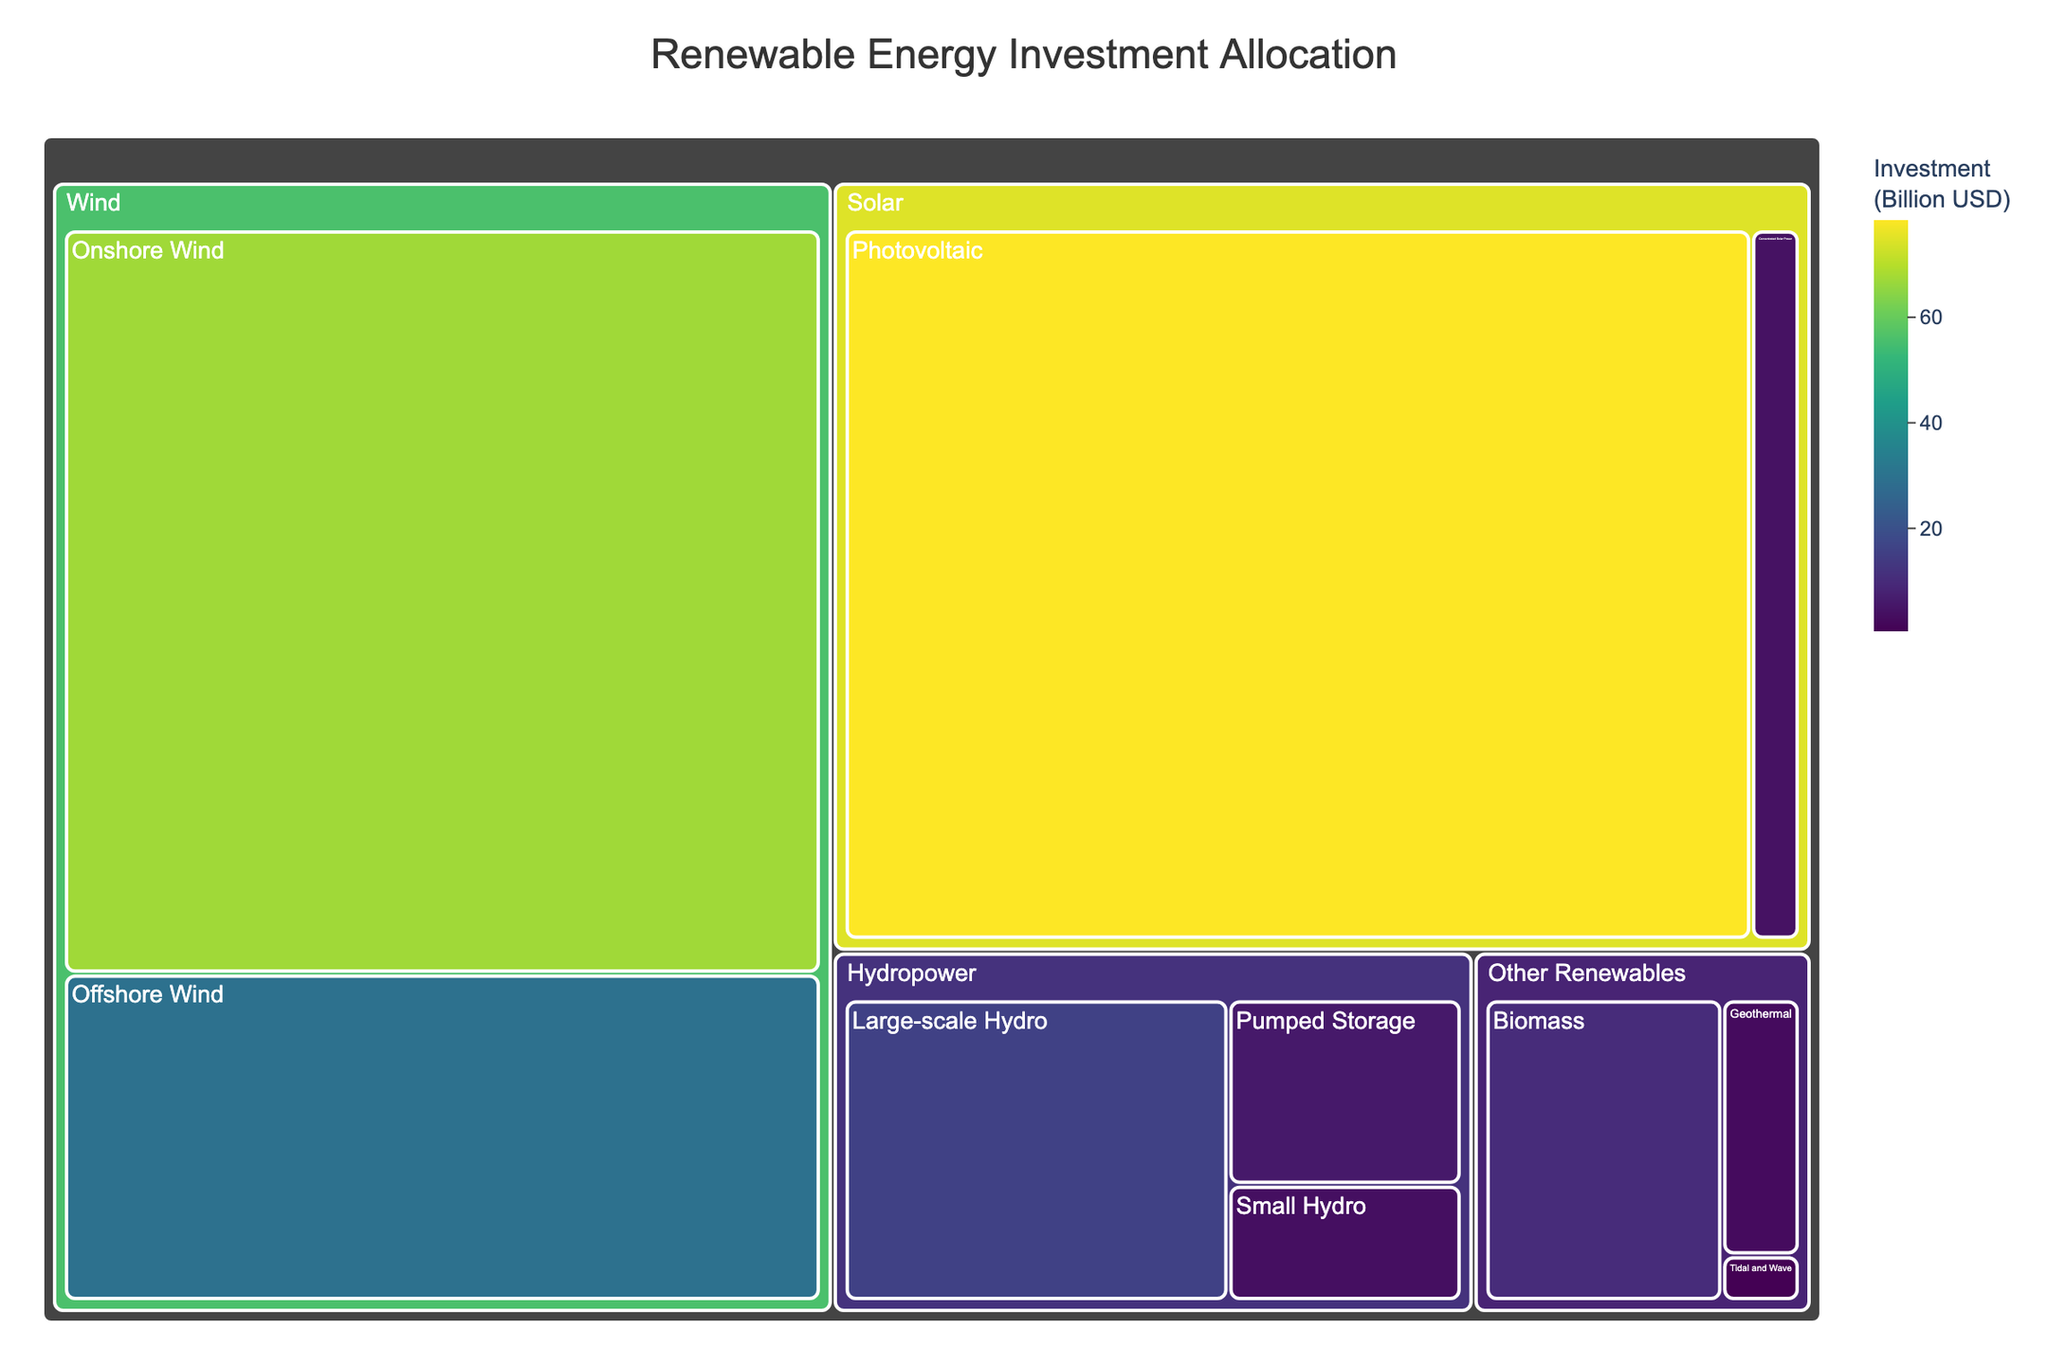What is the total investment in Solar energy? To find the total investment in Solar energy, sum the investments in Photovoltaic and Concentrated Solar Power: 78.5 + 4.2 = 82.7 billion USD
Answer: 82.7 billion USD Which subcategory has the highest investment? The subcategory with the highest investment occurs in the Photovoltaic area under Solar, with an investment of 78.5 billion USD.
Answer: Photovoltaic What is the difference in investment between Onshore Wind and Offshore Wind? The investment in Onshore Wind is 67.3 billion USD, and the investment in Offshore Wind is 29.6 billion USD. The difference is calculated as 67.3 - 29.6 = 37.7 billion USD
Answer: 37.7 billion USD How does the investment in Large-scale Hydro compare to Small Hydro? The investment in Large-scale Hydro is 15.8 billion USD, while the investment in Small Hydro is 3.7 billion USD. The difference is 15.8 - 3.7 = 12.1 billion USD, showing Large-scale Hydro has significantly higher investment.
Answer: Large-scale Hydro is 12.1 billion USD more What percentage of the total investment is allocated to Wind energy? The total investment in Wind energy is the sum of Onshore Wind and Offshore Wind: 67.3 + 29.6 = 96.9 billion USD. To find the percentage, first calculate the total investment across all categories: 78.5 + 4.2 + 67.3 + 29.6 + 15.8 + 3.7 + 5.9 + 2.8 + 10.1 + 0.5 = 218.4 billion USD. Then (96.9 / 218.4) * 100 ≈ 44.4%
Answer: 44.4% What is the average investment in the Hydropower subcategories? The Hydropower subcategories have investments of 15.8, 3.7, and 5.9 billion USD. The average is calculated as (15.8 + 3.7 + 5.9) / 3 = 25.4 / 3 ≈ 8.47 billion USD
Answer: 8.47 billion USD What is the smallest investment shown in the treemap? The smallest investment shown in the treemap is in the Tidal and Wave subcategory under Other Renewables, with an investment of 0.5 billion USD.
Answer: 0.5 billion USD What is the total investment in Other Renewables? The total investment in Other Renewables is the sum of Geothermal, Biomass, and Tidal and Wave: 2.8 + 10.1 + 0.5 = 13.4 billion USD
Answer: 13.4 billion USD Which category has the lowest total investment, and what is the amount? To find the category with the lowest total investment, sum the investments in each category and compare. Hydropower has 15.8 + 3.7 + 5.9 = 25.4 billion USD, which is less than Solar's 82.7 billion USD, Wind's 96.9 billion USD, and Other Renewables' 13.4 billion USD. So, Other Renewables is the lowest with 13.4 billion USD
Answer: Other Renewables, 13.4 billion USD 